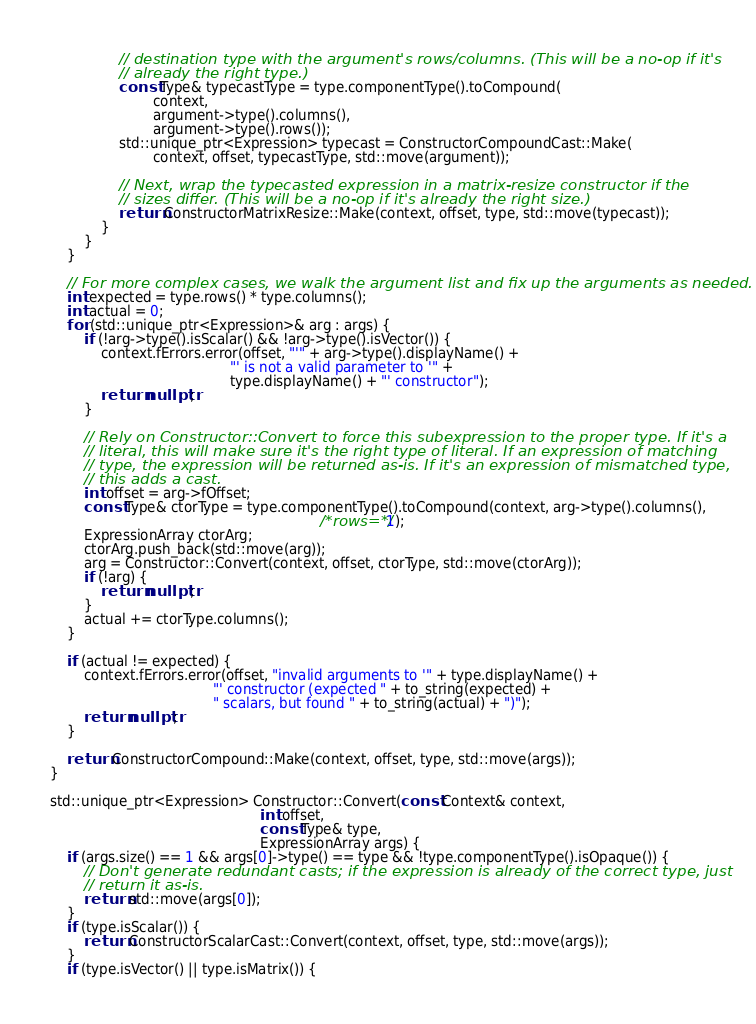Convert code to text. <code><loc_0><loc_0><loc_500><loc_500><_C++_>                // destination type with the argument's rows/columns. (This will be a no-op if it's
                // already the right type.)
                const Type& typecastType = type.componentType().toCompound(
                        context,
                        argument->type().columns(),
                        argument->type().rows());
                std::unique_ptr<Expression> typecast = ConstructorCompoundCast::Make(
                        context, offset, typecastType, std::move(argument));

                // Next, wrap the typecasted expression in a matrix-resize constructor if the
                // sizes differ. (This will be a no-op if it's already the right size.)
                return ConstructorMatrixResize::Make(context, offset, type, std::move(typecast));
            }
        }
    }

    // For more complex cases, we walk the argument list and fix up the arguments as needed.
    int expected = type.rows() * type.columns();
    int actual = 0;
    for (std::unique_ptr<Expression>& arg : args) {
        if (!arg->type().isScalar() && !arg->type().isVector()) {
            context.fErrors.error(offset, "'" + arg->type().displayName() +
                                          "' is not a valid parameter to '" +
                                          type.displayName() + "' constructor");
            return nullptr;
        }

        // Rely on Constructor::Convert to force this subexpression to the proper type. If it's a
        // literal, this will make sure it's the right type of literal. If an expression of matching
        // type, the expression will be returned as-is. If it's an expression of mismatched type,
        // this adds a cast.
        int offset = arg->fOffset;
        const Type& ctorType = type.componentType().toCompound(context, arg->type().columns(),
                                                               /*rows=*/1);
        ExpressionArray ctorArg;
        ctorArg.push_back(std::move(arg));
        arg = Constructor::Convert(context, offset, ctorType, std::move(ctorArg));
        if (!arg) {
            return nullptr;
        }
        actual += ctorType.columns();
    }

    if (actual != expected) {
        context.fErrors.error(offset, "invalid arguments to '" + type.displayName() +
                                      "' constructor (expected " + to_string(expected) +
                                      " scalars, but found " + to_string(actual) + ")");
        return nullptr;
    }

    return ConstructorCompound::Make(context, offset, type, std::move(args));
}

std::unique_ptr<Expression> Constructor::Convert(const Context& context,
                                                 int offset,
                                                 const Type& type,
                                                 ExpressionArray args) {
    if (args.size() == 1 && args[0]->type() == type && !type.componentType().isOpaque()) {
        // Don't generate redundant casts; if the expression is already of the correct type, just
        // return it as-is.
        return std::move(args[0]);
    }
    if (type.isScalar()) {
        return ConstructorScalarCast::Convert(context, offset, type, std::move(args));
    }
    if (type.isVector() || type.isMatrix()) {</code> 